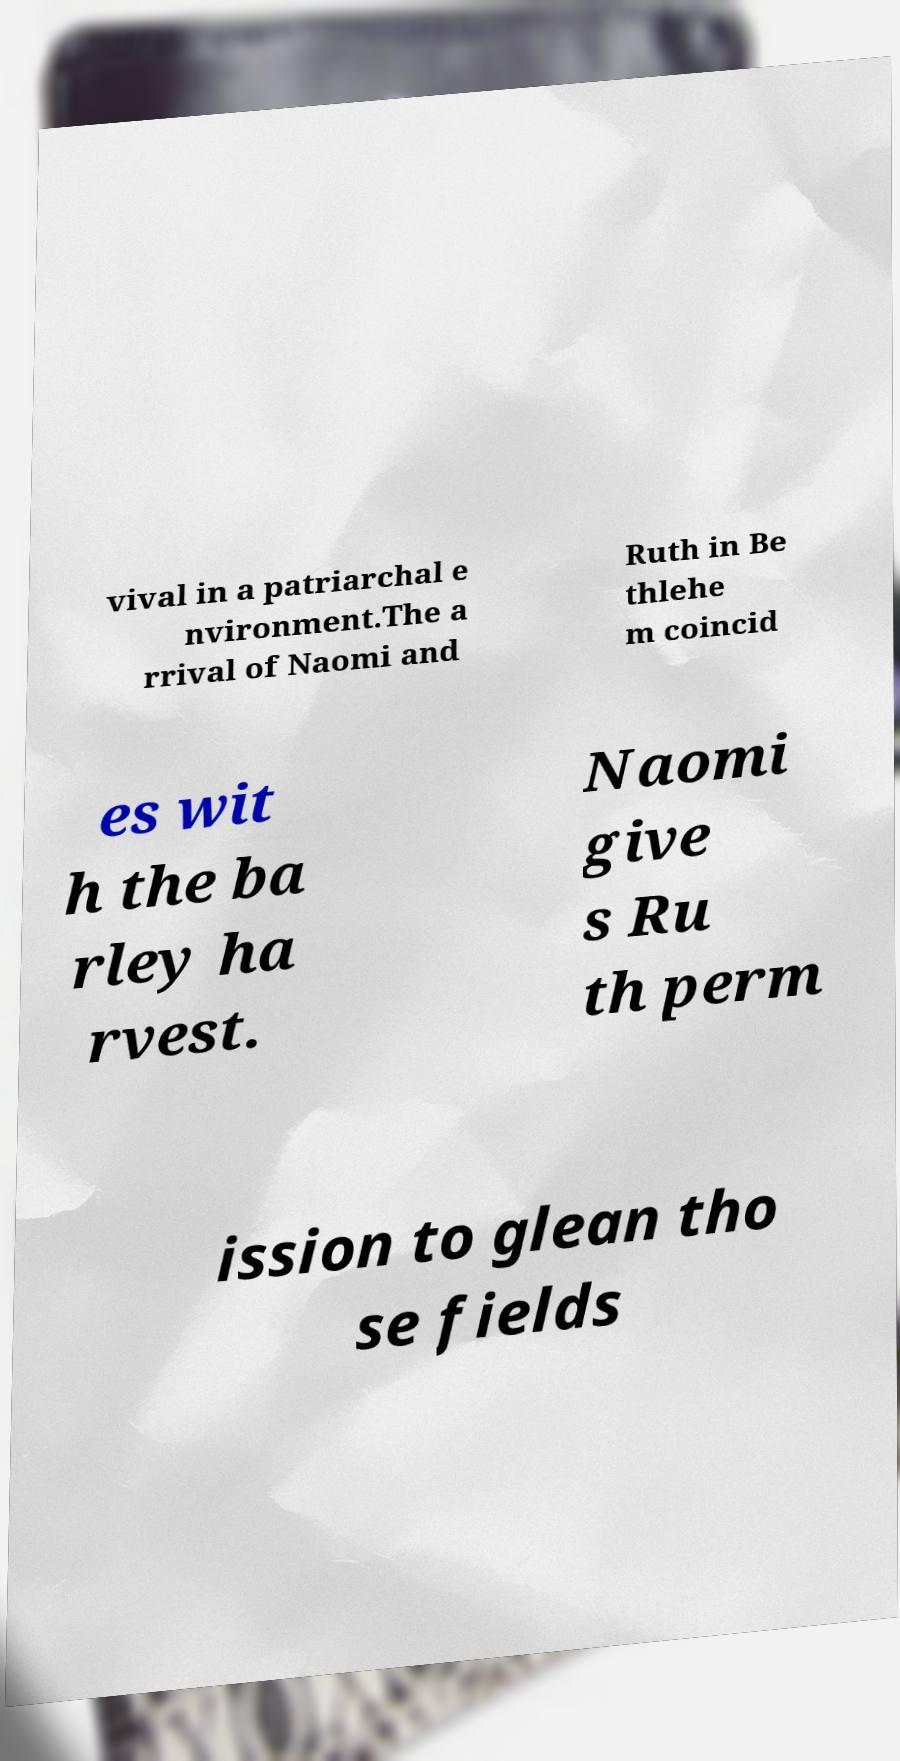There's text embedded in this image that I need extracted. Can you transcribe it verbatim? vival in a patriarchal e nvironment.The a rrival of Naomi and Ruth in Be thlehe m coincid es wit h the ba rley ha rvest. Naomi give s Ru th perm ission to glean tho se fields 